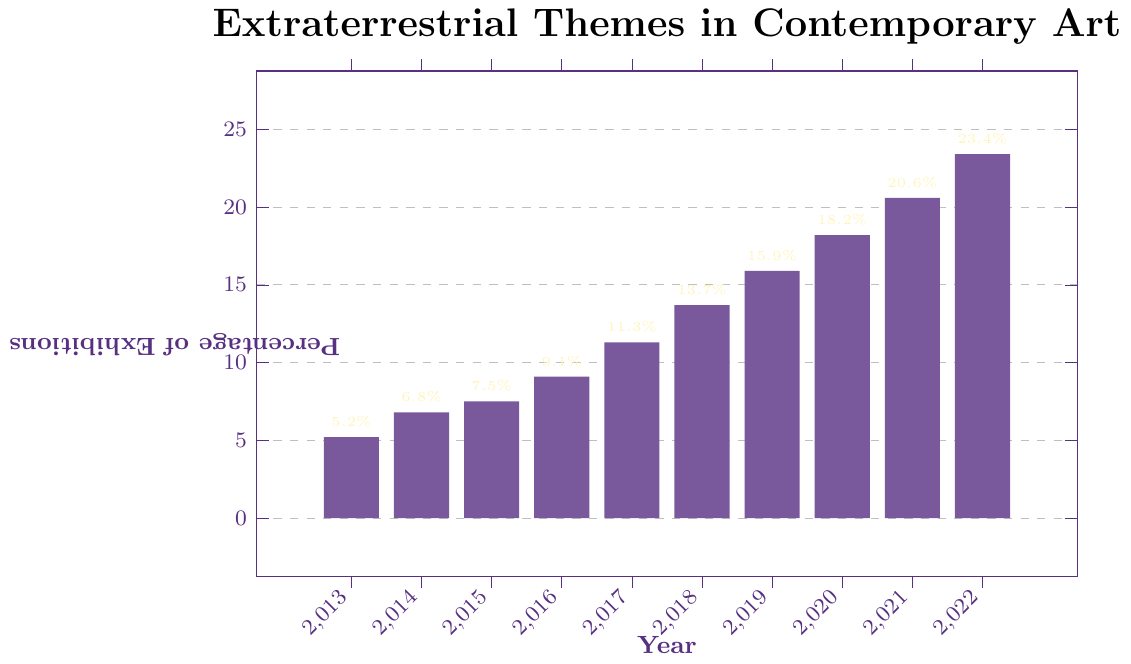what is the percentage change from 2013 to 2022? To find the percentage change, subtract the initial value (2013) from the final value (2022), then divide by the initial value and multiply by 100. (23.4 - 5.2) / 5.2 * 100
Answer: 350% how many years did it take for the percentage of exhibitions to double from its 2013 value The percentage in 2013 is 5.2%. We need to find when it reached approximately 10.4%. By inspecting the data, this occurred between 2015 (7.5%) and 2016 (9.1%)
Answer: Between 2 and 3 years which year saw the highest increase in percentage compared to the previous year? Subtract the previous year's percentage from the current year's percentage for each year and determine the maximum value: (2014-2013 = 1.6%, 2015-2014 = 0.7%, 2016-2015 = 1.6%, 2017-2016 = 2.2%, 2018-2017 = 2.4%, 2019-2018 = 2.2%, 2020-2019 = 2.3%, 2021-2020 = 2.4%, 2022-2021 = 2.8%)
Answer: 2022 what is the average percentage of exhibitions with extraterrestrial themes over the decade? Sum all the percentages from 2013 to 2022 and divide by the number of years (10). (5.2 + 6.8 + 7.5 + 9.1 + 11.3 + 13.7 + 15.9 + 18.2 + 20.6 + 23.4) / 10 = 13.17%
Answer: 13.17% is the growth trend of extraterrestrial themes in exhibitions increasing or decreasing? By observing the bar heights, we note that each subsequent year has a higher percentage than the previous, indicating a consistent upward trend
Answer: Increasing 